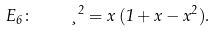Convert formula to latex. <formula><loc_0><loc_0><loc_500><loc_500>E _ { 6 } \colon \quad \xi ^ { 2 } = x \, ( 1 + x - x ^ { 2 } ) .</formula> 